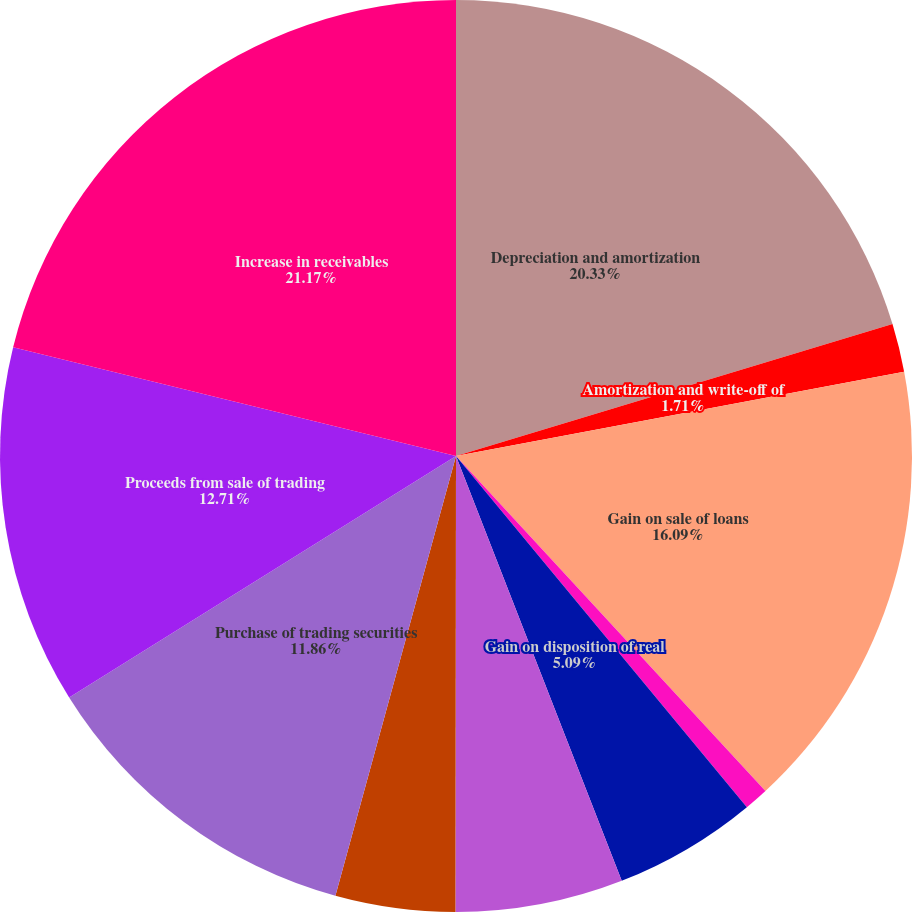<chart> <loc_0><loc_0><loc_500><loc_500><pie_chart><fcel>Depreciation and amortization<fcel>Amortization and write-off of<fcel>Gain on sale of loans<fcel>Net realized and unrealized<fcel>Gain on disposition of real<fcel>Deferred income taxes<fcel>Distribution of earnings from<fcel>Purchase of trading securities<fcel>Proceeds from sale of trading<fcel>Increase in receivables<nl><fcel>20.33%<fcel>1.71%<fcel>16.09%<fcel>0.86%<fcel>5.09%<fcel>5.94%<fcel>4.24%<fcel>11.86%<fcel>12.71%<fcel>21.17%<nl></chart> 